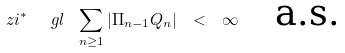<formula> <loc_0><loc_0><loc_500><loc_500>\ z i ^ { * } \ \ g l \ \sum _ { n \geq 1 } | \Pi _ { n - 1 } Q _ { n } | \ < \ \infty \quad \text {a.s.}</formula> 